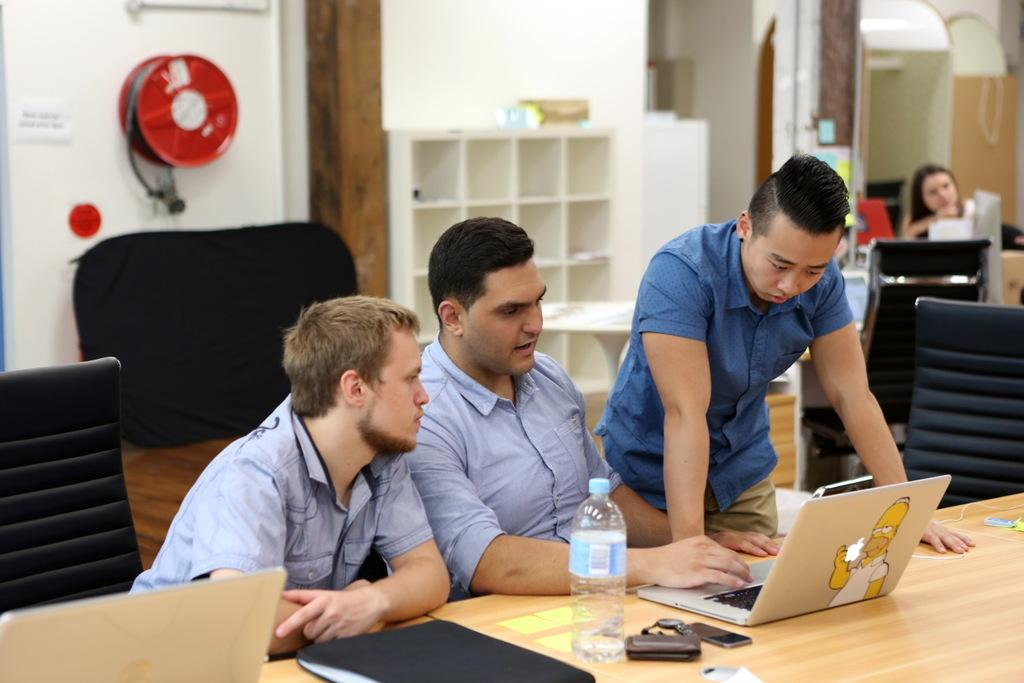How many men are sitting in the middle of the image? There are two men sitting in the middle of the image. What are the sitting men doing? The sitting men are looking at a laptop. What is the standing man wearing? The standing man is wearing a blue color shirt. Where is the girl located in the image? The girl is on the right side of the image. Can you tell me how many goldfish are swimming in the image? There are no goldfish present in the image. What type of wing is attached to the girl's back in the image? There is no wing attached to the girl's back in the image. 